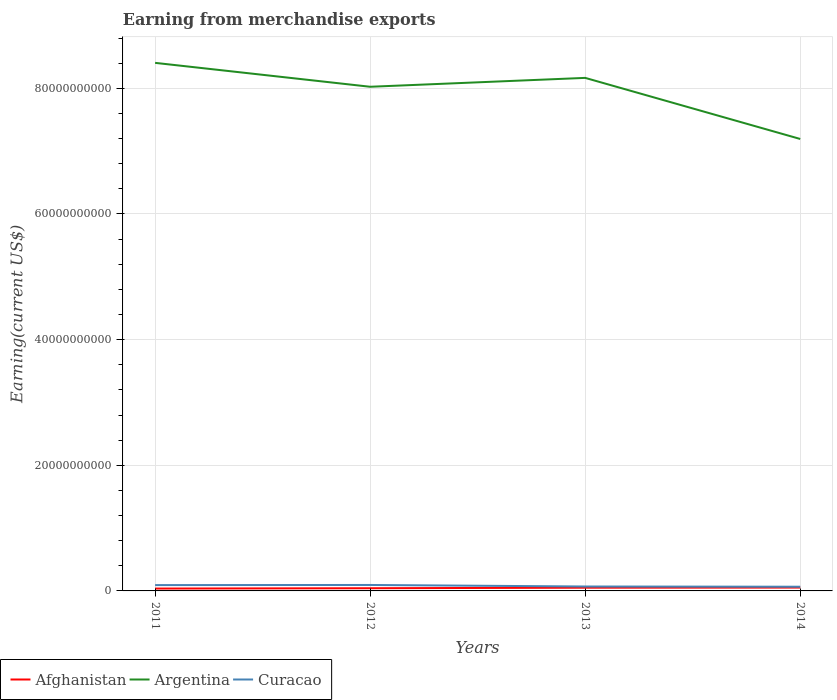Across all years, what is the maximum amount earned from merchandise exports in Argentina?
Your answer should be compact. 7.19e+1. What is the total amount earned from merchandise exports in Argentina in the graph?
Your answer should be very brief. -1.41e+09. What is the difference between the highest and the second highest amount earned from merchandise exports in Argentina?
Keep it short and to the point. 1.21e+1. What is the difference between the highest and the lowest amount earned from merchandise exports in Afghanistan?
Provide a short and direct response. 2. How many lines are there?
Give a very brief answer. 3. Does the graph contain grids?
Ensure brevity in your answer.  Yes. Where does the legend appear in the graph?
Keep it short and to the point. Bottom left. How many legend labels are there?
Provide a succinct answer. 3. What is the title of the graph?
Make the answer very short. Earning from merchandise exports. What is the label or title of the X-axis?
Offer a very short reply. Years. What is the label or title of the Y-axis?
Your response must be concise. Earning(current US$). What is the Earning(current US$) in Afghanistan in 2011?
Provide a succinct answer. 3.76e+08. What is the Earning(current US$) of Argentina in 2011?
Make the answer very short. 8.41e+1. What is the Earning(current US$) in Curacao in 2011?
Your response must be concise. 9.28e+08. What is the Earning(current US$) of Afghanistan in 2012?
Make the answer very short. 4.29e+08. What is the Earning(current US$) of Argentina in 2012?
Ensure brevity in your answer.  8.02e+1. What is the Earning(current US$) in Curacao in 2012?
Offer a very short reply. 9.48e+08. What is the Earning(current US$) in Afghanistan in 2013?
Ensure brevity in your answer.  5.15e+08. What is the Earning(current US$) in Argentina in 2013?
Provide a short and direct response. 8.17e+1. What is the Earning(current US$) of Curacao in 2013?
Your answer should be compact. 7.05e+08. What is the Earning(current US$) of Afghanistan in 2014?
Your response must be concise. 5.35e+08. What is the Earning(current US$) in Argentina in 2014?
Provide a succinct answer. 7.19e+1. What is the Earning(current US$) in Curacao in 2014?
Your response must be concise. 6.70e+08. Across all years, what is the maximum Earning(current US$) of Afghanistan?
Your answer should be very brief. 5.35e+08. Across all years, what is the maximum Earning(current US$) in Argentina?
Your answer should be compact. 8.41e+1. Across all years, what is the maximum Earning(current US$) in Curacao?
Make the answer very short. 9.48e+08. Across all years, what is the minimum Earning(current US$) in Afghanistan?
Offer a terse response. 3.76e+08. Across all years, what is the minimum Earning(current US$) of Argentina?
Your response must be concise. 7.19e+1. Across all years, what is the minimum Earning(current US$) of Curacao?
Keep it short and to the point. 6.70e+08. What is the total Earning(current US$) of Afghanistan in the graph?
Offer a very short reply. 1.85e+09. What is the total Earning(current US$) of Argentina in the graph?
Your answer should be compact. 3.18e+11. What is the total Earning(current US$) of Curacao in the graph?
Provide a short and direct response. 3.25e+09. What is the difference between the Earning(current US$) in Afghanistan in 2011 and that in 2012?
Ensure brevity in your answer.  -5.31e+07. What is the difference between the Earning(current US$) in Argentina in 2011 and that in 2012?
Keep it short and to the point. 3.80e+09. What is the difference between the Earning(current US$) of Curacao in 2011 and that in 2012?
Offer a very short reply. -1.99e+07. What is the difference between the Earning(current US$) of Afghanistan in 2011 and that in 2013?
Provide a short and direct response. -1.39e+08. What is the difference between the Earning(current US$) in Argentina in 2011 and that in 2013?
Your answer should be very brief. 2.39e+09. What is the difference between the Earning(current US$) in Curacao in 2011 and that in 2013?
Give a very brief answer. 2.24e+08. What is the difference between the Earning(current US$) in Afghanistan in 2011 and that in 2014?
Keep it short and to the point. -1.59e+08. What is the difference between the Earning(current US$) in Argentina in 2011 and that in 2014?
Make the answer very short. 1.21e+1. What is the difference between the Earning(current US$) in Curacao in 2011 and that in 2014?
Offer a terse response. 2.58e+08. What is the difference between the Earning(current US$) in Afghanistan in 2012 and that in 2013?
Offer a very short reply. -8.61e+07. What is the difference between the Earning(current US$) of Argentina in 2012 and that in 2013?
Keep it short and to the point. -1.41e+09. What is the difference between the Earning(current US$) in Curacao in 2012 and that in 2013?
Ensure brevity in your answer.  2.44e+08. What is the difference between the Earning(current US$) of Afghanistan in 2012 and that in 2014?
Give a very brief answer. -1.06e+08. What is the difference between the Earning(current US$) in Argentina in 2012 and that in 2014?
Make the answer very short. 8.31e+09. What is the difference between the Earning(current US$) of Curacao in 2012 and that in 2014?
Offer a terse response. 2.78e+08. What is the difference between the Earning(current US$) of Afghanistan in 2013 and that in 2014?
Ensure brevity in your answer.  -2.00e+07. What is the difference between the Earning(current US$) in Argentina in 2013 and that in 2014?
Ensure brevity in your answer.  9.72e+09. What is the difference between the Earning(current US$) in Curacao in 2013 and that in 2014?
Keep it short and to the point. 3.45e+07. What is the difference between the Earning(current US$) of Afghanistan in 2011 and the Earning(current US$) of Argentina in 2012?
Provide a succinct answer. -7.99e+1. What is the difference between the Earning(current US$) of Afghanistan in 2011 and the Earning(current US$) of Curacao in 2012?
Offer a terse response. -5.72e+08. What is the difference between the Earning(current US$) in Argentina in 2011 and the Earning(current US$) in Curacao in 2012?
Your answer should be very brief. 8.31e+1. What is the difference between the Earning(current US$) in Afghanistan in 2011 and the Earning(current US$) in Argentina in 2013?
Provide a short and direct response. -8.13e+1. What is the difference between the Earning(current US$) of Afghanistan in 2011 and the Earning(current US$) of Curacao in 2013?
Your response must be concise. -3.29e+08. What is the difference between the Earning(current US$) of Argentina in 2011 and the Earning(current US$) of Curacao in 2013?
Offer a very short reply. 8.33e+1. What is the difference between the Earning(current US$) in Afghanistan in 2011 and the Earning(current US$) in Argentina in 2014?
Your answer should be compact. -7.16e+1. What is the difference between the Earning(current US$) of Afghanistan in 2011 and the Earning(current US$) of Curacao in 2014?
Make the answer very short. -2.94e+08. What is the difference between the Earning(current US$) of Argentina in 2011 and the Earning(current US$) of Curacao in 2014?
Keep it short and to the point. 8.34e+1. What is the difference between the Earning(current US$) in Afghanistan in 2012 and the Earning(current US$) in Argentina in 2013?
Keep it short and to the point. -8.12e+1. What is the difference between the Earning(current US$) in Afghanistan in 2012 and the Earning(current US$) in Curacao in 2013?
Keep it short and to the point. -2.76e+08. What is the difference between the Earning(current US$) of Argentina in 2012 and the Earning(current US$) of Curacao in 2013?
Provide a short and direct response. 7.95e+1. What is the difference between the Earning(current US$) of Afghanistan in 2012 and the Earning(current US$) of Argentina in 2014?
Offer a very short reply. -7.15e+1. What is the difference between the Earning(current US$) of Afghanistan in 2012 and the Earning(current US$) of Curacao in 2014?
Ensure brevity in your answer.  -2.41e+08. What is the difference between the Earning(current US$) in Argentina in 2012 and the Earning(current US$) in Curacao in 2014?
Give a very brief answer. 7.96e+1. What is the difference between the Earning(current US$) of Afghanistan in 2013 and the Earning(current US$) of Argentina in 2014?
Offer a terse response. -7.14e+1. What is the difference between the Earning(current US$) in Afghanistan in 2013 and the Earning(current US$) in Curacao in 2014?
Your answer should be very brief. -1.55e+08. What is the difference between the Earning(current US$) of Argentina in 2013 and the Earning(current US$) of Curacao in 2014?
Your response must be concise. 8.10e+1. What is the average Earning(current US$) in Afghanistan per year?
Offer a very short reply. 4.64e+08. What is the average Earning(current US$) in Argentina per year?
Your answer should be compact. 7.95e+1. What is the average Earning(current US$) of Curacao per year?
Provide a short and direct response. 8.13e+08. In the year 2011, what is the difference between the Earning(current US$) of Afghanistan and Earning(current US$) of Argentina?
Your response must be concise. -8.37e+1. In the year 2011, what is the difference between the Earning(current US$) of Afghanistan and Earning(current US$) of Curacao?
Provide a short and direct response. -5.52e+08. In the year 2011, what is the difference between the Earning(current US$) of Argentina and Earning(current US$) of Curacao?
Ensure brevity in your answer.  8.31e+1. In the year 2012, what is the difference between the Earning(current US$) in Afghanistan and Earning(current US$) in Argentina?
Your answer should be compact. -7.98e+1. In the year 2012, what is the difference between the Earning(current US$) of Afghanistan and Earning(current US$) of Curacao?
Your response must be concise. -5.19e+08. In the year 2012, what is the difference between the Earning(current US$) of Argentina and Earning(current US$) of Curacao?
Give a very brief answer. 7.93e+1. In the year 2013, what is the difference between the Earning(current US$) in Afghanistan and Earning(current US$) in Argentina?
Offer a terse response. -8.11e+1. In the year 2013, what is the difference between the Earning(current US$) of Afghanistan and Earning(current US$) of Curacao?
Provide a succinct answer. -1.90e+08. In the year 2013, what is the difference between the Earning(current US$) in Argentina and Earning(current US$) in Curacao?
Provide a succinct answer. 8.10e+1. In the year 2014, what is the difference between the Earning(current US$) in Afghanistan and Earning(current US$) in Argentina?
Your response must be concise. -7.14e+1. In the year 2014, what is the difference between the Earning(current US$) in Afghanistan and Earning(current US$) in Curacao?
Provide a succinct answer. -1.35e+08. In the year 2014, what is the difference between the Earning(current US$) in Argentina and Earning(current US$) in Curacao?
Offer a terse response. 7.13e+1. What is the ratio of the Earning(current US$) of Afghanistan in 2011 to that in 2012?
Your answer should be very brief. 0.88. What is the ratio of the Earning(current US$) in Argentina in 2011 to that in 2012?
Your answer should be compact. 1.05. What is the ratio of the Earning(current US$) in Curacao in 2011 to that in 2012?
Make the answer very short. 0.98. What is the ratio of the Earning(current US$) of Afghanistan in 2011 to that in 2013?
Keep it short and to the point. 0.73. What is the ratio of the Earning(current US$) in Argentina in 2011 to that in 2013?
Make the answer very short. 1.03. What is the ratio of the Earning(current US$) of Curacao in 2011 to that in 2013?
Provide a short and direct response. 1.32. What is the ratio of the Earning(current US$) of Afghanistan in 2011 to that in 2014?
Offer a terse response. 0.7. What is the ratio of the Earning(current US$) in Argentina in 2011 to that in 2014?
Provide a succinct answer. 1.17. What is the ratio of the Earning(current US$) of Curacao in 2011 to that in 2014?
Provide a short and direct response. 1.39. What is the ratio of the Earning(current US$) of Afghanistan in 2012 to that in 2013?
Provide a succinct answer. 0.83. What is the ratio of the Earning(current US$) in Argentina in 2012 to that in 2013?
Provide a succinct answer. 0.98. What is the ratio of the Earning(current US$) of Curacao in 2012 to that in 2013?
Make the answer very short. 1.35. What is the ratio of the Earning(current US$) of Afghanistan in 2012 to that in 2014?
Provide a short and direct response. 0.8. What is the ratio of the Earning(current US$) of Argentina in 2012 to that in 2014?
Offer a very short reply. 1.12. What is the ratio of the Earning(current US$) in Curacao in 2012 to that in 2014?
Ensure brevity in your answer.  1.42. What is the ratio of the Earning(current US$) of Afghanistan in 2013 to that in 2014?
Offer a very short reply. 0.96. What is the ratio of the Earning(current US$) of Argentina in 2013 to that in 2014?
Provide a short and direct response. 1.14. What is the ratio of the Earning(current US$) of Curacao in 2013 to that in 2014?
Provide a short and direct response. 1.05. What is the difference between the highest and the second highest Earning(current US$) in Afghanistan?
Give a very brief answer. 2.00e+07. What is the difference between the highest and the second highest Earning(current US$) of Argentina?
Your answer should be compact. 2.39e+09. What is the difference between the highest and the second highest Earning(current US$) in Curacao?
Keep it short and to the point. 1.99e+07. What is the difference between the highest and the lowest Earning(current US$) of Afghanistan?
Ensure brevity in your answer.  1.59e+08. What is the difference between the highest and the lowest Earning(current US$) in Argentina?
Make the answer very short. 1.21e+1. What is the difference between the highest and the lowest Earning(current US$) in Curacao?
Ensure brevity in your answer.  2.78e+08. 